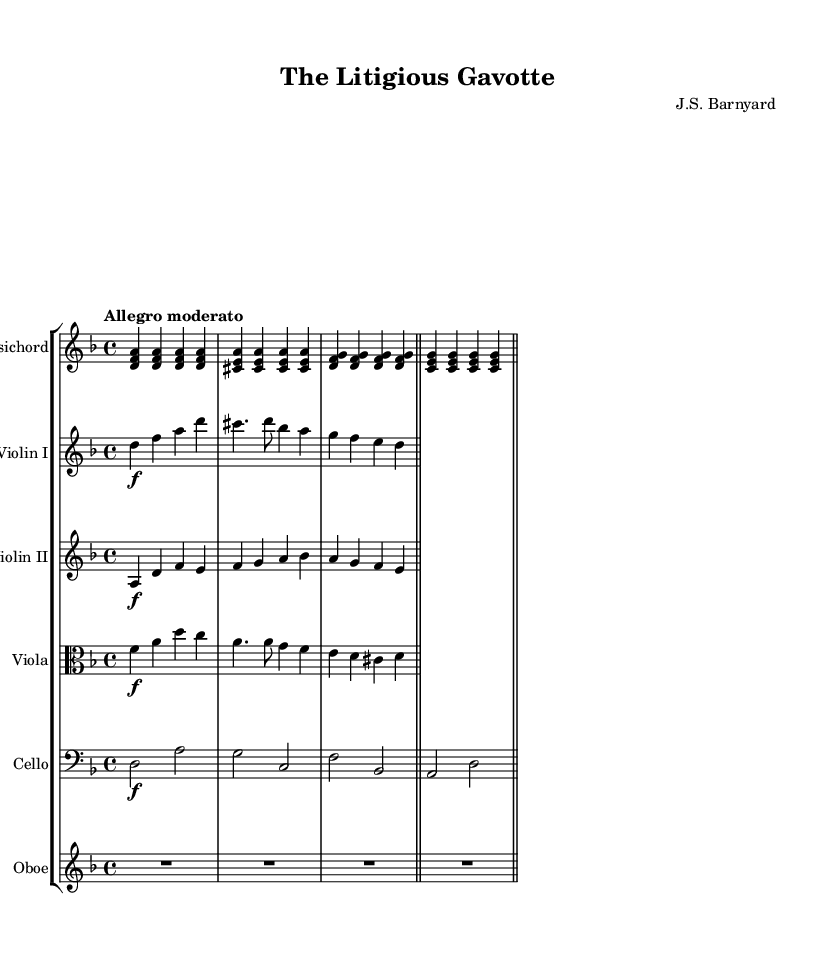What is the key signature of this music? The key signature is D minor, which contains one flat (B flat) and aligns with the notes found throughout the piece.
Answer: D minor What is the time signature of this music? The time signature is 4/4, indicating four beats per measure, which can be confirmed by observing the regular grouping of notes in each measure.
Answer: 4/4 What is the name of the composition? The title of the composition is "The Litigious Gavotte," as indicated at the top of the sheet music.
Answer: The Litigious Gavotte What is the tempo marking for this piece? The tempo marking is "Allegro moderato," suggesting a moderately fast pace, which is specified in the header section of the music.
Answer: Allegro moderato How many instruments are in this composition? There are five instruments included in the score: Harpsichord, Violin I, Violin II, Viola, Cello, and Oboe, as denoted by their respective staff labels.
Answer: Five Which instrument has the lowest pitch? The instrument with the lowest pitch is the Cello, which is notated on the bass clef, confirming its role as the lowest in the ensemble.
Answer: Cello Which section of the music does the Oboe play? The Oboe plays a rest for the entire measure in this section, indicated by the notation in its respective staff.
Answer: Rest 